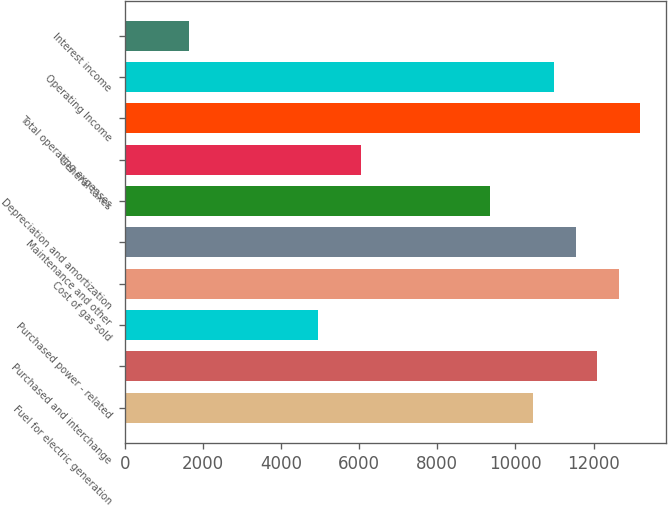Convert chart. <chart><loc_0><loc_0><loc_500><loc_500><bar_chart><fcel>Fuel for electric generation<fcel>Purchased and interchange<fcel>Purchased power - related<fcel>Cost of gas sold<fcel>Maintenance and other<fcel>Depreciation and amortization<fcel>General taxes<fcel>Total operating expenses<fcel>Operating Income<fcel>Interest income<nl><fcel>10448.2<fcel>12097.6<fcel>4950.2<fcel>12647.4<fcel>11547.8<fcel>9348.6<fcel>6049.8<fcel>13197.2<fcel>10998<fcel>1651.4<nl></chart> 